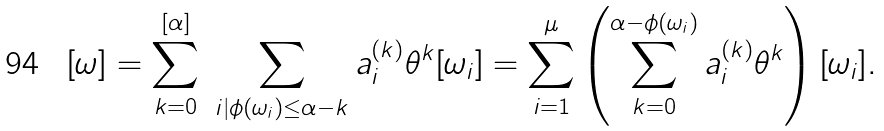<formula> <loc_0><loc_0><loc_500><loc_500>[ \omega ] = \sum _ { k = 0 } ^ { [ \alpha ] } \ \sum _ { i | \phi ( \omega _ { i } ) \leq \alpha - k } a _ { i } ^ { ( k ) } \theta ^ { k } [ \omega _ { i } ] = \sum _ { i = 1 } ^ { \mu } \left ( \sum _ { k = 0 } ^ { \alpha - \phi ( \omega _ { i } ) } a _ { i } ^ { ( k ) } \theta ^ { k } \right ) [ \omega _ { i } ] .</formula> 